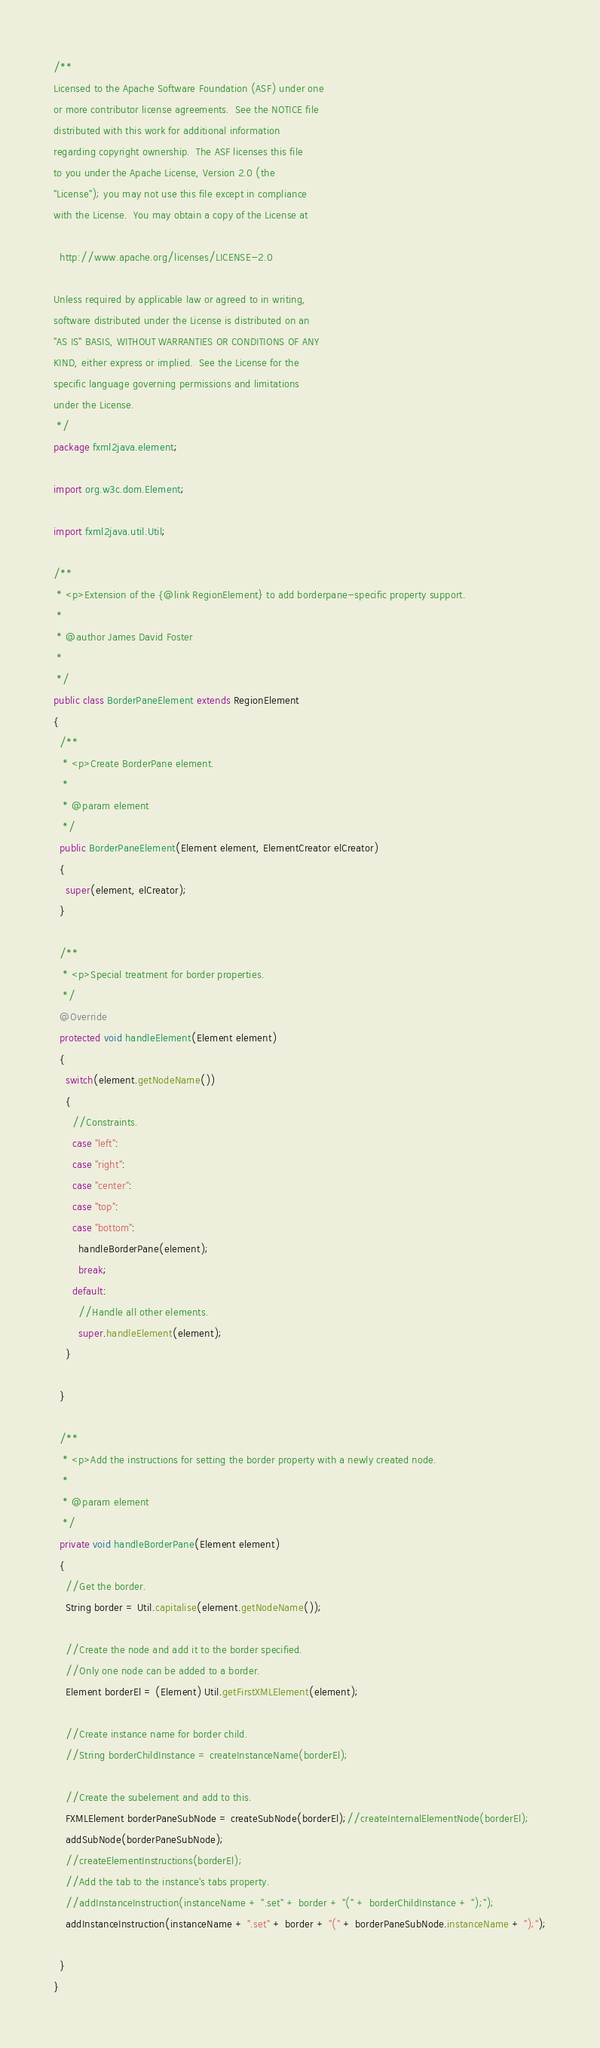Convert code to text. <code><loc_0><loc_0><loc_500><loc_500><_Java_>/**
Licensed to the Apache Software Foundation (ASF) under one
or more contributor license agreements.  See the NOTICE file
distributed with this work for additional information
regarding copyright ownership.  The ASF licenses this file
to you under the Apache License, Version 2.0 (the
"License"); you may not use this file except in compliance
with the License.  You may obtain a copy of the License at

  http://www.apache.org/licenses/LICENSE-2.0

Unless required by applicable law or agreed to in writing,
software distributed under the License is distributed on an
"AS IS" BASIS, WITHOUT WARRANTIES OR CONDITIONS OF ANY
KIND, either express or implied.  See the License for the
specific language governing permissions and limitations
under the License.    
 */
package fxml2java.element;

import org.w3c.dom.Element;

import fxml2java.util.Util;

/**
 * <p>Extension of the {@link RegionElement} to add borderpane-specific property support.  
 * 
 * @author James David Foster
 *
 */
public class BorderPaneElement extends RegionElement
{  
  /**
   * <p>Create BorderPane element.
   * 
   * @param element
   */
  public BorderPaneElement(Element element, ElementCreator elCreator)
  {
    super(element, elCreator);
  }

  /**
   * <p>Special treatment for border properties.
   */
  @Override
  protected void handleElement(Element element)
  {
    switch(element.getNodeName())
    {
      //Constraints.
      case "left":
      case "right":
      case "center":
      case "top":
      case "bottom":
        handleBorderPane(element);
        break;
      default:
        //Handle all other elements.
        super.handleElement(element);
    }
    
  }

  /**
   * <p>Add the instructions for setting the border property with a newly created node.
   * 
   * @param element
   */
  private void handleBorderPane(Element element)
  {
    //Get the border.
    String border = Util.capitalise(element.getNodeName());
    
    //Create the node and add it to the border specified.
    //Only one node can be added to a border.
    Element borderEl = (Element) Util.getFirstXMLElement(element);
    
    //Create instance name for border child.
    //String borderChildInstance = createInstanceName(borderEl);
    
    //Create the subelement and add to this.
    FXMLElement borderPaneSubNode = createSubNode(borderEl);//createInternalElementNode(borderEl);
    addSubNode(borderPaneSubNode);
    //createElementInstructions(borderEl);
    //Add the tab to the instance's tabs property.
    //addInstanceInstruction(instanceName + ".set" + border + "(" + borderChildInstance + ");");
    addInstanceInstruction(instanceName + ".set" + border + "(" + borderPaneSubNode.instanceName + ");");
    
  }
}
</code> 